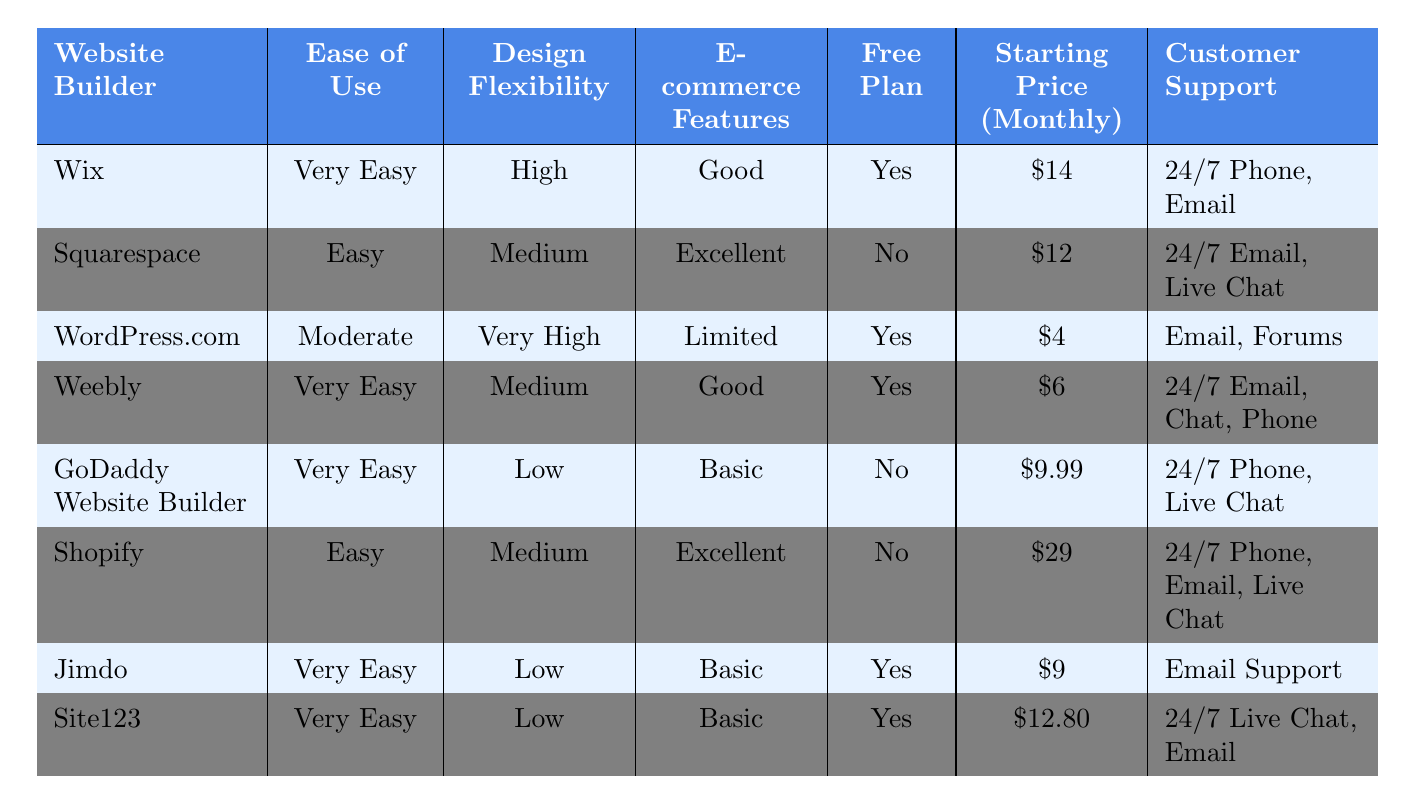What is the website builder with the highest ease of use? By examining the “Ease of Use” column in the table, “Wix” has a rating of “Very Easy,” which is the highest given.
Answer: Wix Which website builder has the lowest starting price per month? The “Starting Price (Monthly)” column shows that “WordPress.com” has the lowest price of $4 per month.
Answer: WordPress.com Is there a website builder that offers a free plan? The “Free Plan” column indicates that both “Wix” and “WordPress.com” have a free plan available, so the answer is yes.
Answer: Yes How many website builders offer 24/7 customer support? Checking the “Customer Support” column reveals that “Wix,” “Weebly,” and “Shopify” provide 24/7 support, totaling three builders.
Answer: 3 What is the average starting price among the website builders listed in the table? The starting prices are: $14 (Wix), $12 (Squarespace), $4 (WordPress.com), $6 (Weebly), $9.99 (GoDaddy), $29 (Shopify), $9 (Jimdo), $12.80 (Site123). Adding these gives $92.79, and dividing by 8 provides an average of $11.60.
Answer: $11.60 Which website builder has the best e-commerce features? From the “E-commerce Features” column, “Squarespace” and “Shopify” are rated “Excellent,” indicating they have the best features for e-commerce.
Answer: Squarespace and Shopify How many website builders are rated as "Very Easy" in terms of ease of use? The “Ease of Use” column shows that “Wix,” “Weebly,” “GoDaddy Website Builder,” “Jimdo,” and “Site123” are rated “Very Easy,” totaling five builders.
Answer: 5 What distinguishes Shopify's e-commerce features from WordPress.com? “Shopify” is rated “Excellent” for e-commerce features, while “WordPress.com” is rated “Limited,” indicating a significant difference in e-commerce capabilities.
Answer: Shopify has Excellent; WordPress.com has Limited Which website builder has a free plan but charges more than $9 per month? Examining the table, “Jimdo” offers a free plan and has a starting price of $9, while “Site123” has a free plan and costs $12.80, making Site123 the answer.
Answer: Site123 